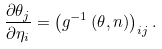<formula> <loc_0><loc_0><loc_500><loc_500>\frac { \partial \theta _ { j } } { \partial \eta _ { i } } = \left ( g ^ { - 1 } \left ( \theta , n \right ) \right ) _ { i j } .</formula> 